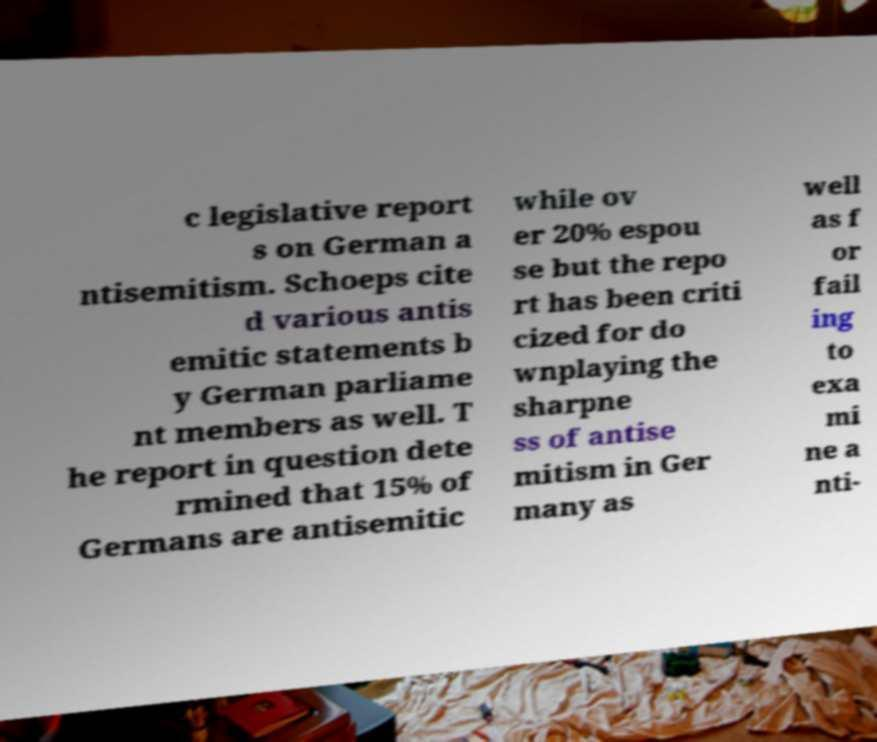I need the written content from this picture converted into text. Can you do that? c legislative report s on German a ntisemitism. Schoeps cite d various antis emitic statements b y German parliame nt members as well. T he report in question dete rmined that 15% of Germans are antisemitic while ov er 20% espou se but the repo rt has been criti cized for do wnplaying the sharpne ss of antise mitism in Ger many as well as f or fail ing to exa mi ne a nti- 